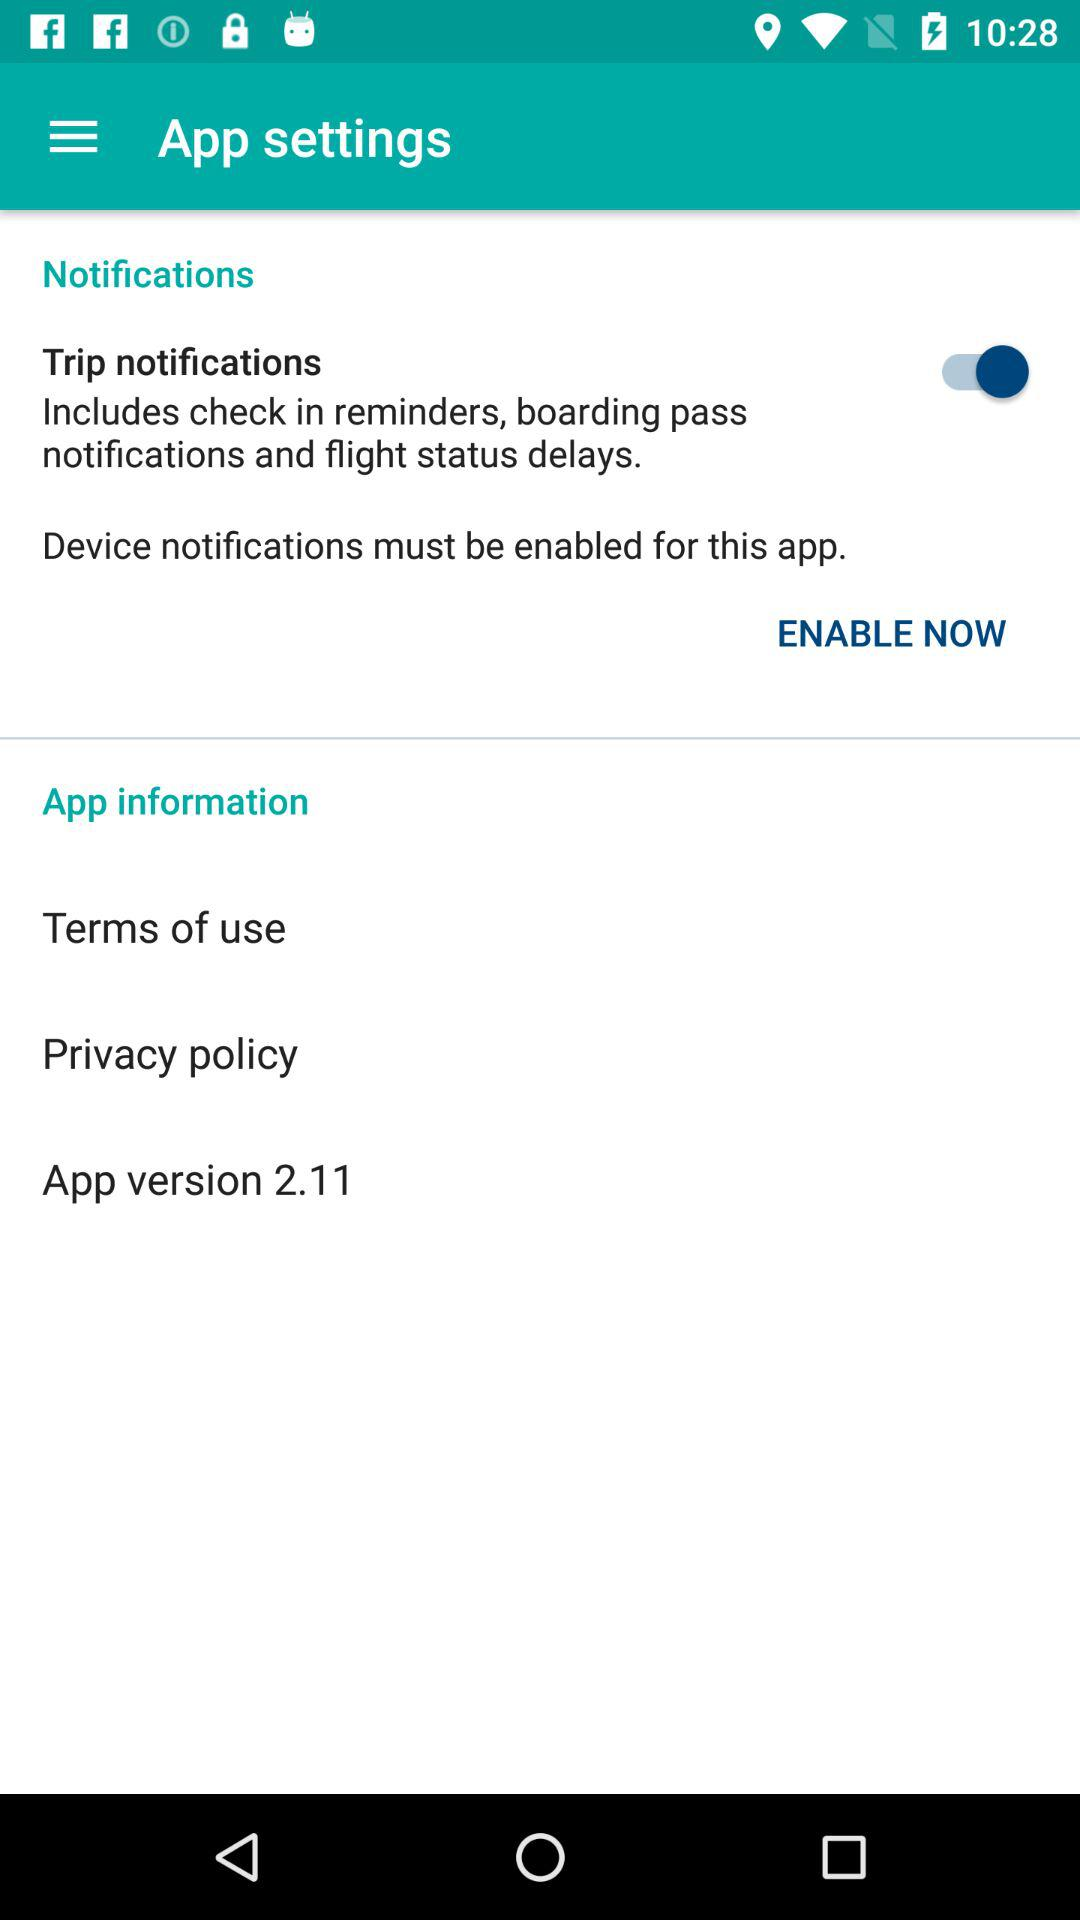What is the status of "Trip notifications"? The status is "on". 